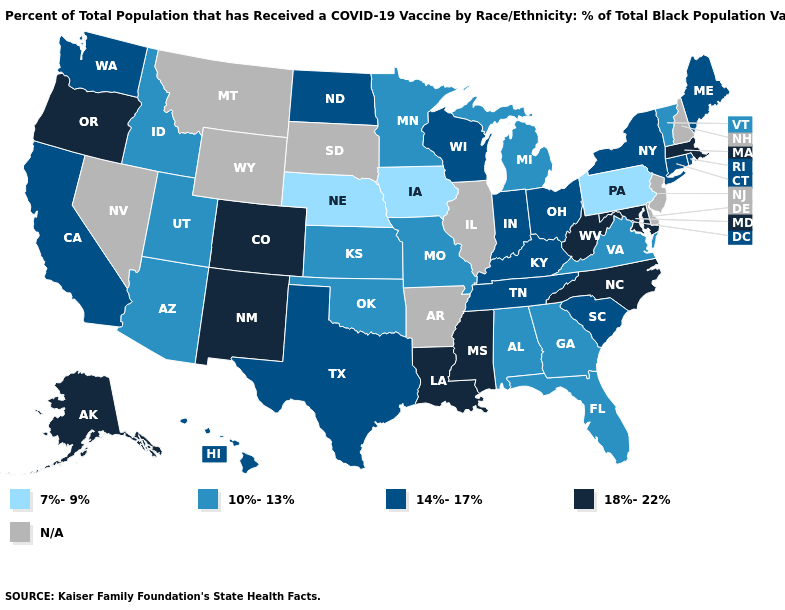Name the states that have a value in the range N/A?
Concise answer only. Arkansas, Delaware, Illinois, Montana, Nevada, New Hampshire, New Jersey, South Dakota, Wyoming. What is the highest value in the USA?
Quick response, please. 18%-22%. Among the states that border Indiana , which have the highest value?
Concise answer only. Kentucky, Ohio. Is the legend a continuous bar?
Quick response, please. No. What is the lowest value in the South?
Keep it brief. 10%-13%. Among the states that border North Carolina , does South Carolina have the highest value?
Write a very short answer. Yes. What is the highest value in states that border Indiana?
Concise answer only. 14%-17%. What is the value of Missouri?
Answer briefly. 10%-13%. Which states hav the highest value in the Northeast?
Short answer required. Massachusetts. Name the states that have a value in the range 14%-17%?
Keep it brief. California, Connecticut, Hawaii, Indiana, Kentucky, Maine, New York, North Dakota, Ohio, Rhode Island, South Carolina, Tennessee, Texas, Washington, Wisconsin. Which states have the lowest value in the USA?
Answer briefly. Iowa, Nebraska, Pennsylvania. Name the states that have a value in the range 14%-17%?
Concise answer only. California, Connecticut, Hawaii, Indiana, Kentucky, Maine, New York, North Dakota, Ohio, Rhode Island, South Carolina, Tennessee, Texas, Washington, Wisconsin. 